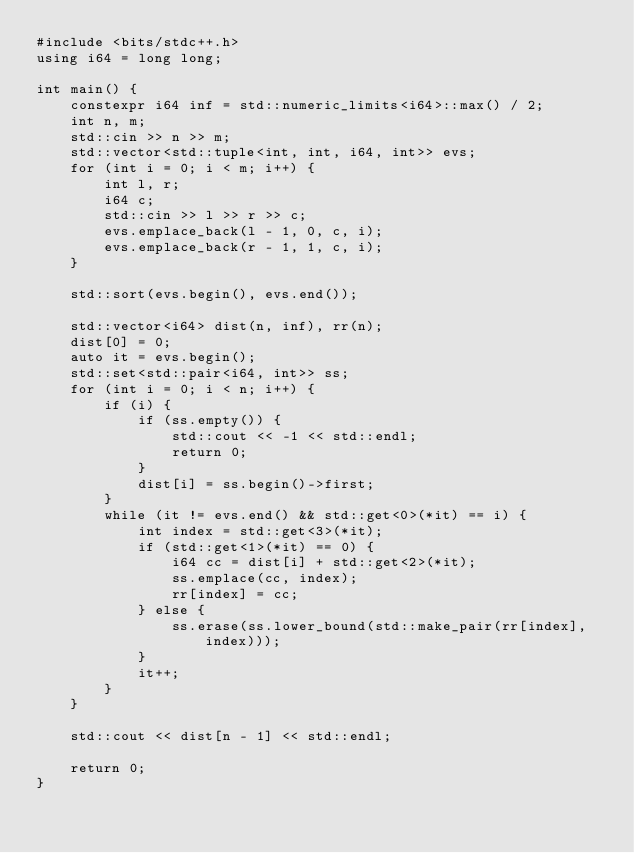<code> <loc_0><loc_0><loc_500><loc_500><_C++_>#include <bits/stdc++.h>
using i64 = long long;

int main() {
    constexpr i64 inf = std::numeric_limits<i64>::max() / 2;
    int n, m;
    std::cin >> n >> m;
    std::vector<std::tuple<int, int, i64, int>> evs;
    for (int i = 0; i < m; i++) {
        int l, r;
        i64 c;
        std::cin >> l >> r >> c;
        evs.emplace_back(l - 1, 0, c, i);
        evs.emplace_back(r - 1, 1, c, i);
    }

    std::sort(evs.begin(), evs.end());

    std::vector<i64> dist(n, inf), rr(n);
    dist[0] = 0;
    auto it = evs.begin();
    std::set<std::pair<i64, int>> ss;
    for (int i = 0; i < n; i++) {
        if (i) {
            if (ss.empty()) {
                std::cout << -1 << std::endl;
                return 0;
            }
            dist[i] = ss.begin()->first;
        }
        while (it != evs.end() && std::get<0>(*it) == i) {
            int index = std::get<3>(*it);
            if (std::get<1>(*it) == 0) {
                i64 cc = dist[i] + std::get<2>(*it);
                ss.emplace(cc, index);
                rr[index] = cc;
            } else {
                ss.erase(ss.lower_bound(std::make_pair(rr[index], index)));
            }
            it++;
        }
    }

    std::cout << dist[n - 1] << std::endl;

    return 0;
}
</code> 